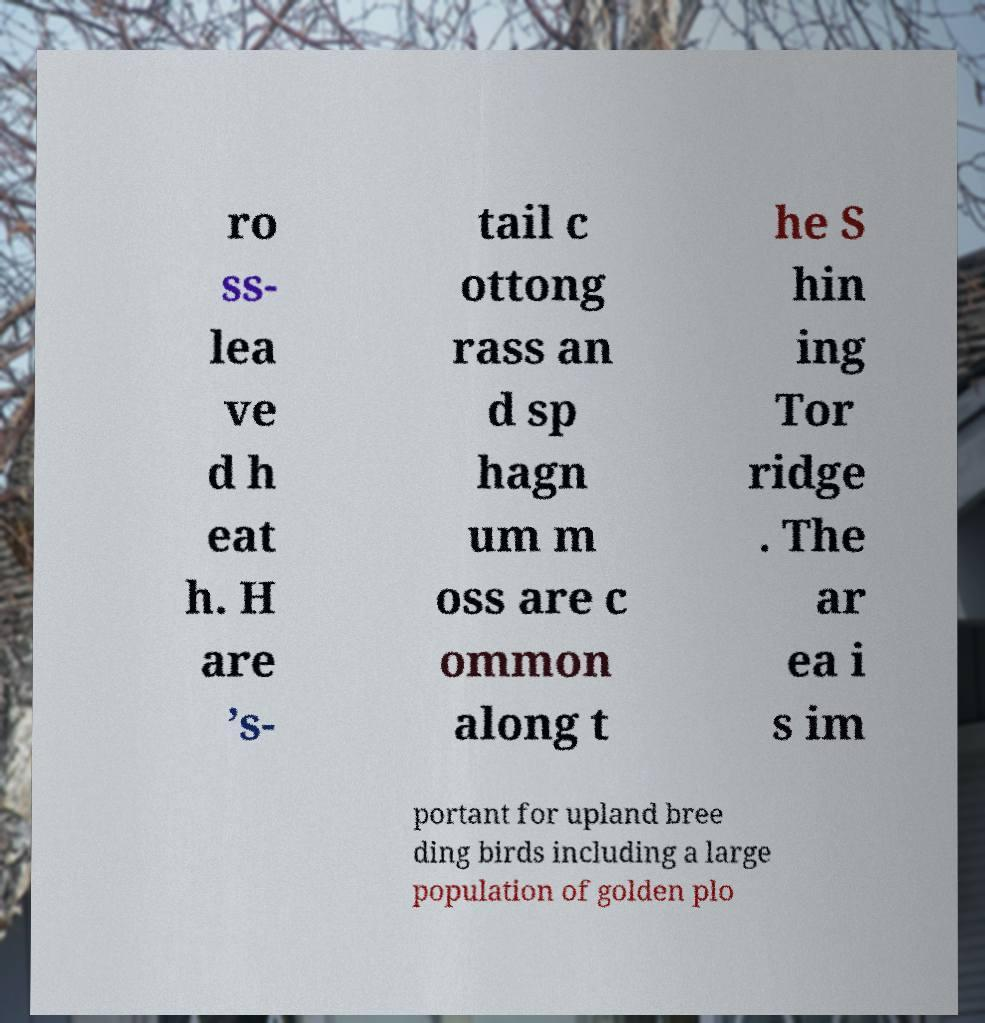For documentation purposes, I need the text within this image transcribed. Could you provide that? ro ss- lea ve d h eat h. H are ’s- tail c ottong rass an d sp hagn um m oss are c ommon along t he S hin ing Tor ridge . The ar ea i s im portant for upland bree ding birds including a large population of golden plo 